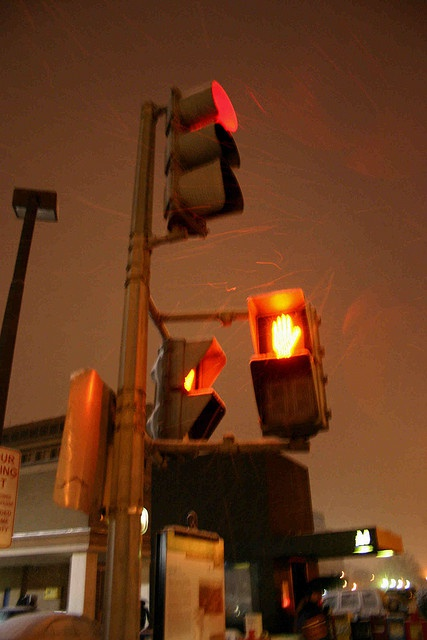Describe the objects in this image and their specific colors. I can see traffic light in black, maroon, and red tones, traffic light in black, maroon, and red tones, traffic light in black, maroon, brown, and red tones, car in black, maroon, and gray tones, and car in black, gray, and maroon tones in this image. 